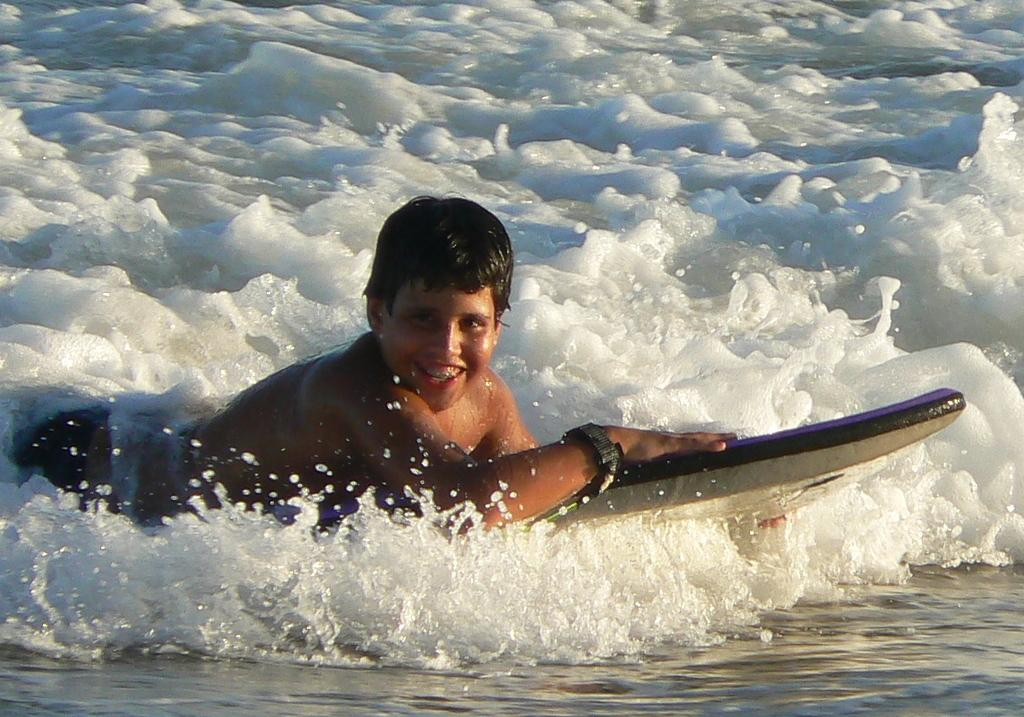Who is the main subject in the image? There is a boy in the image. What is the boy doing in the image? The boy is surfing in water. What time is shown on the clock in the image? There is no clock present in the image. How many hands are visible in the image? There are no hands visible in the image. 